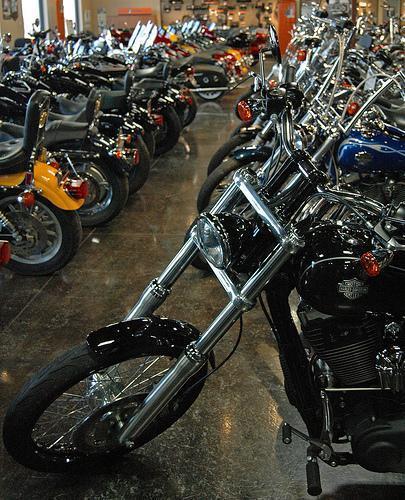How many people are getting on motors?
Give a very brief answer. 0. 